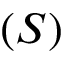Convert formula to latex. <formula><loc_0><loc_0><loc_500><loc_500>( S )</formula> 